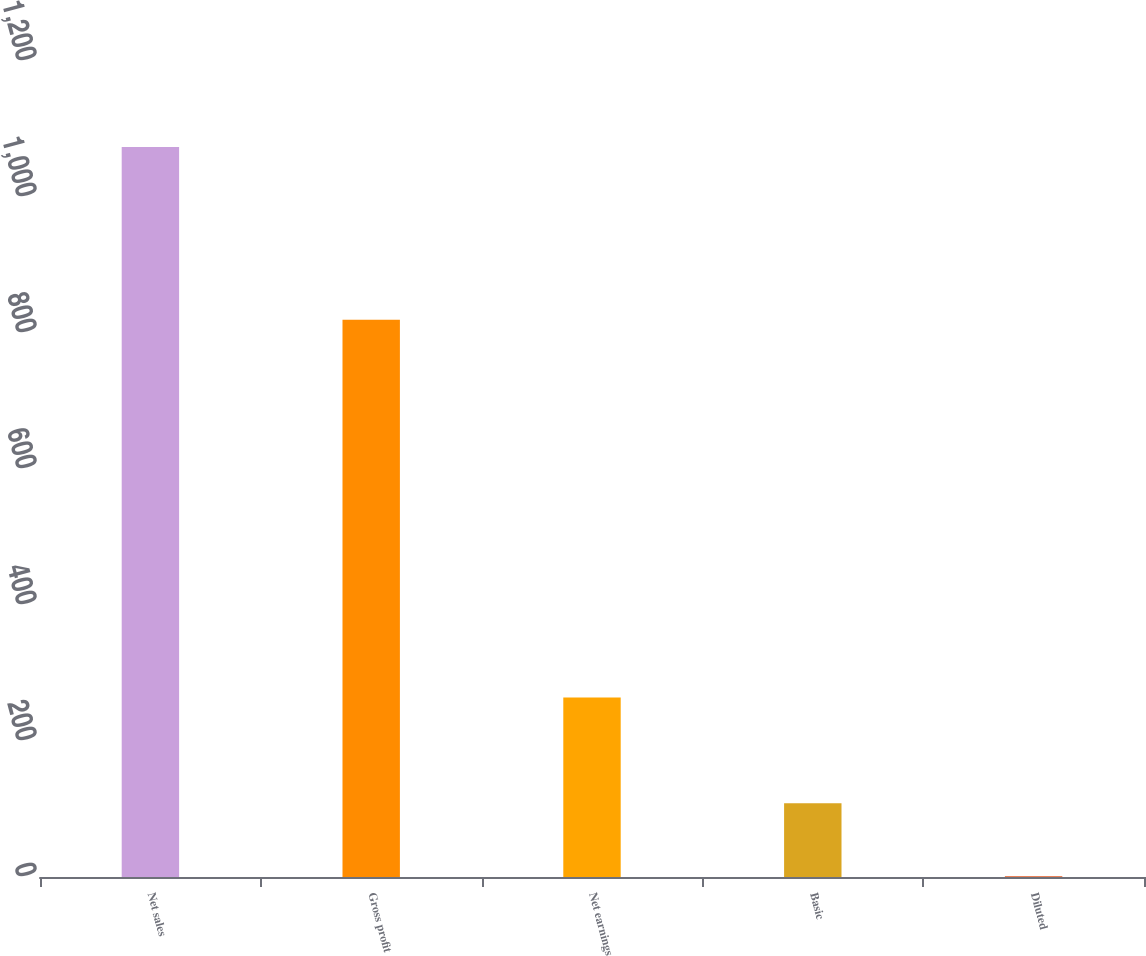Convert chart. <chart><loc_0><loc_0><loc_500><loc_500><bar_chart><fcel>Net sales<fcel>Gross profit<fcel>Net earnings<fcel>Basic<fcel>Diluted<nl><fcel>1073.5<fcel>819.6<fcel>263.8<fcel>108.36<fcel>1.12<nl></chart> 